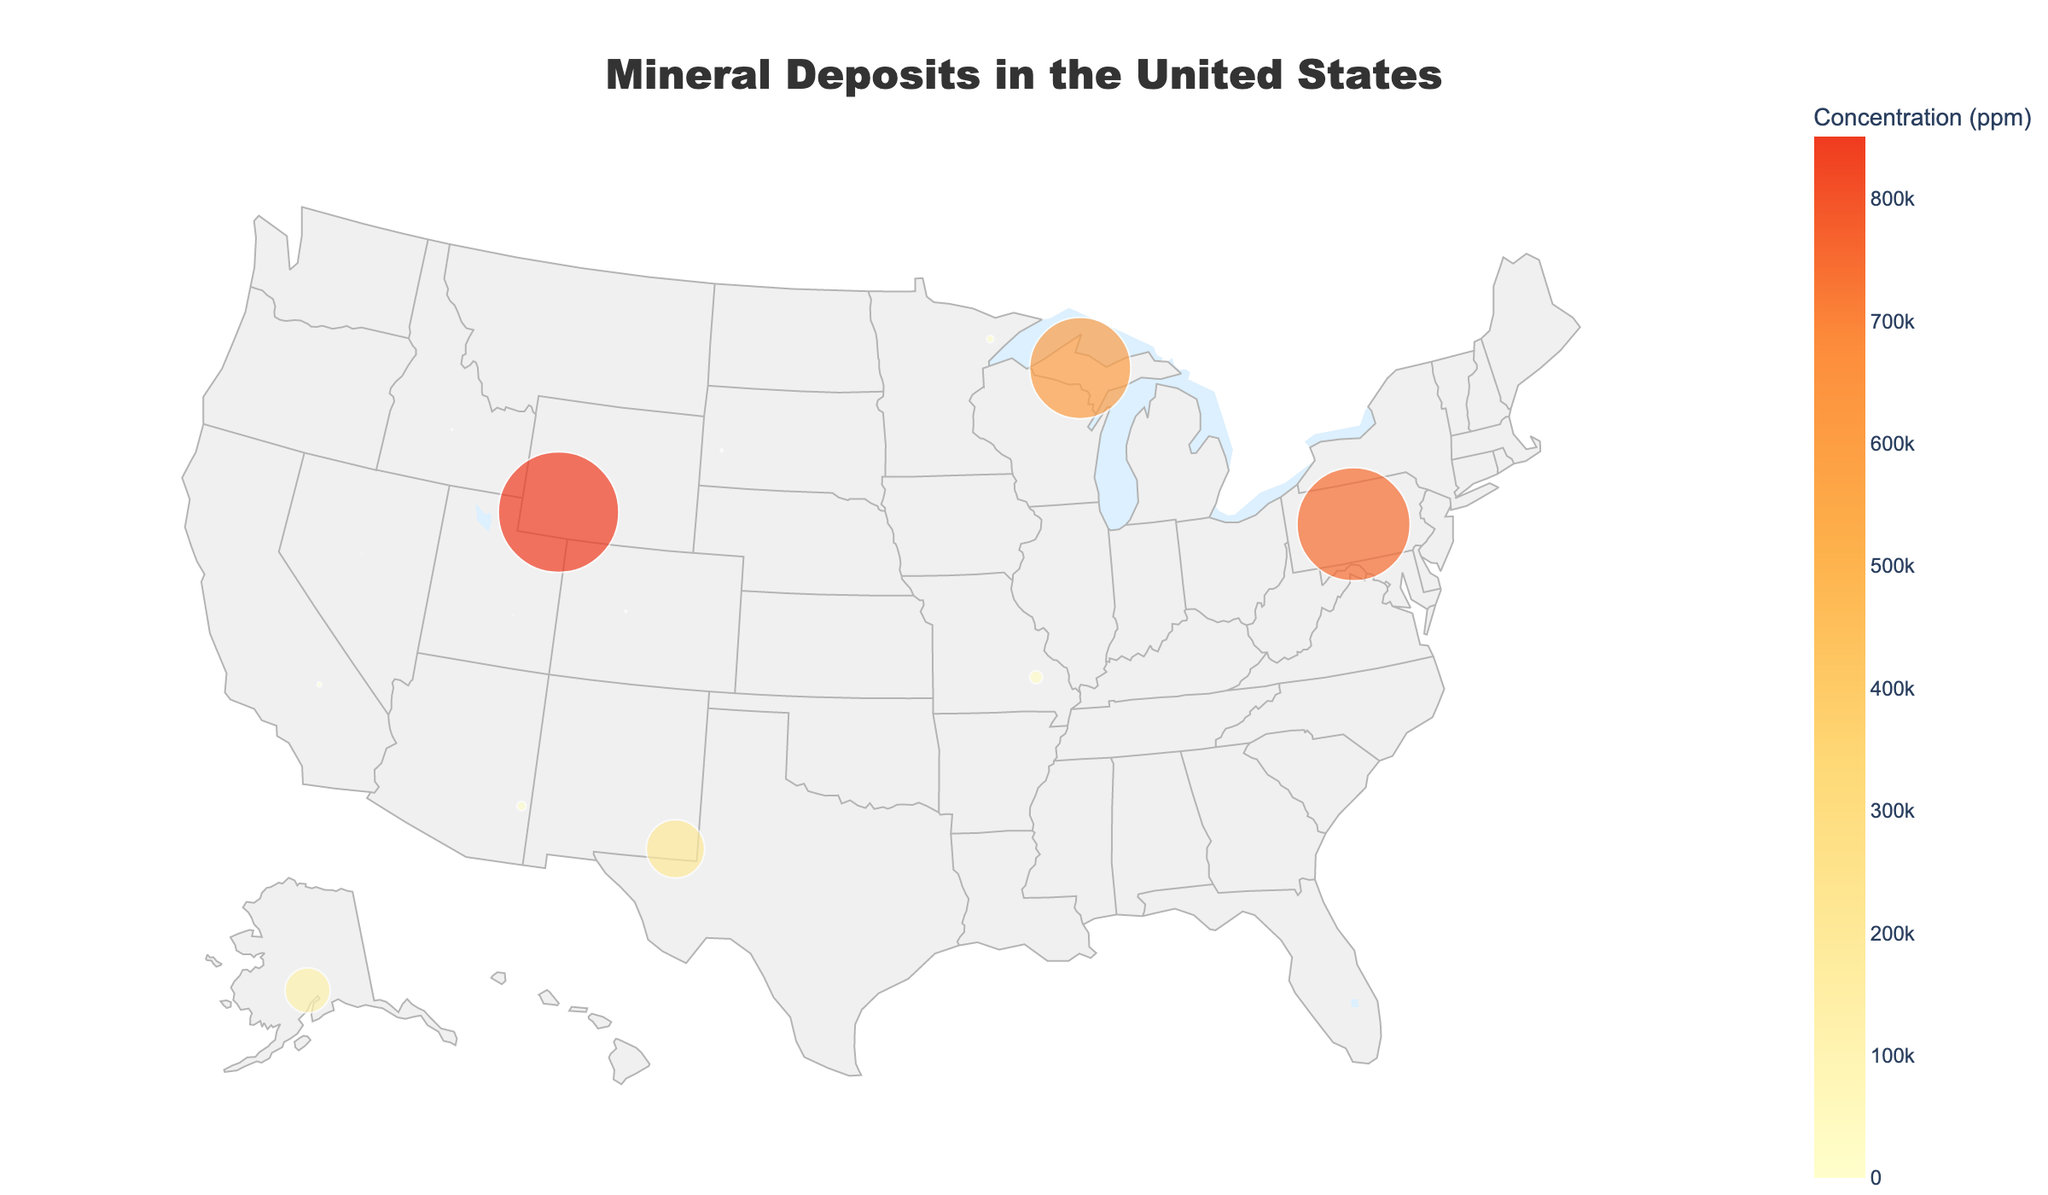what is the title of the figure? The title is present at the top center of the figure and is used to describe the main topic or subject of the visualization.
Answer: Mineral Deposits in the United States Which state has the highest concentration of minerals? By observing the size of the plotted points, which represents concentration, and checking the tooltip information, the largest point corresponds to Wyoming for Trona.
Answer: Wyoming What mineral is found in California according to the figure? By looking at the label annotations near the plotted points within the region corresponding to California, it's possible to see the mineral name.
Answer: Rare Earth Elements How many states show mineral concentrations greater than 100,000 ppm? By scanning the figure for points larger than a specific size threshold and confirming the exact values in the tooltips, we find that Wyoming (Trona), Michigan (Iron), Pennsylvania (Coal), and Alaska (Zinc) exceed this value.
Answer: 4 What is the median concentration of minerals for the states shown on the figure? First, list all concentrations: 0.5, 8.5, 15, 100, 400, 250, 3,000, 5,000, 10,000, 15,000, 100,000, 12,000, 85,000, 120,000. Arrange them in ascending order and find the middle value (or the average of the two middle values if the list length is even).
Answer: 7,500 Which states show concentrations of Copper and Gold, and which has a higher concentration? By looking at the labels and tooltips for each state: Arizona shows Copper (5000 ppm), and Nevada shows Gold (8.5 ppm). Comparing these values shows Copper in Arizona has a higher concentration.
Answer: Copper (Arizona) Which state has the lowest concentration of minerals according to the plot? By checking the label annotations and tooltip information for each point, Montana is identified with a concentration of 0.5 ppm for Platinum.
Answer: Montana What mineral concentration is indicated in New Mexico, and how does it compare to that in South Dakota? According to the labels and tooltips, New Mexico has Potash (200,000 ppm), and South Dakota has Lithium (400 ppm). Potash has a much higher concentration.
Answer: Potash (New Mexico) Is there a state where Lead is significantly concentrated, and what is the ppm? By examining the size of the markers and checking the labels and tooltips, Missouri is identified with a Lead concentration of 10,000 ppm.
Answer: Missouri 